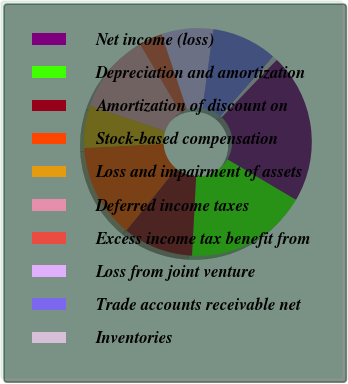<chart> <loc_0><loc_0><loc_500><loc_500><pie_chart><fcel>Net income (loss)<fcel>Depreciation and amortization<fcel>Amortization of discount on<fcel>Stock-based compensation<fcel>Loss and impairment of assets<fcel>Deferred income taxes<fcel>Excess income tax benefit from<fcel>Loss from joint venture<fcel>Trade accounts receivable net<fcel>Inventories<nl><fcel>21.33%<fcel>17.33%<fcel>10.0%<fcel>13.33%<fcel>6.0%<fcel>11.33%<fcel>3.33%<fcel>7.33%<fcel>9.33%<fcel>0.67%<nl></chart> 